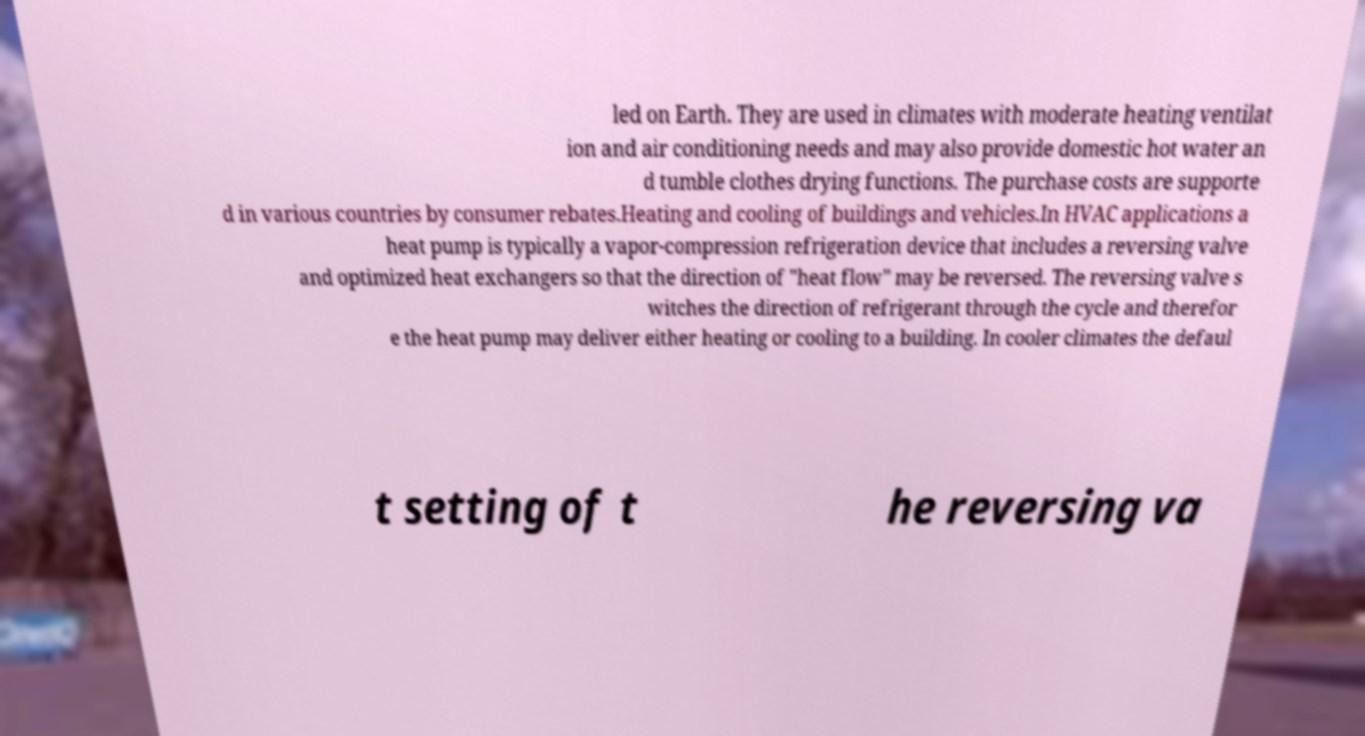Can you accurately transcribe the text from the provided image for me? led on Earth. They are used in climates with moderate heating ventilat ion and air conditioning needs and may also provide domestic hot water an d tumble clothes drying functions. The purchase costs are supporte d in various countries by consumer rebates.Heating and cooling of buildings and vehicles.In HVAC applications a heat pump is typically a vapor-compression refrigeration device that includes a reversing valve and optimized heat exchangers so that the direction of "heat flow" may be reversed. The reversing valve s witches the direction of refrigerant through the cycle and therefor e the heat pump may deliver either heating or cooling to a building. In cooler climates the defaul t setting of t he reversing va 